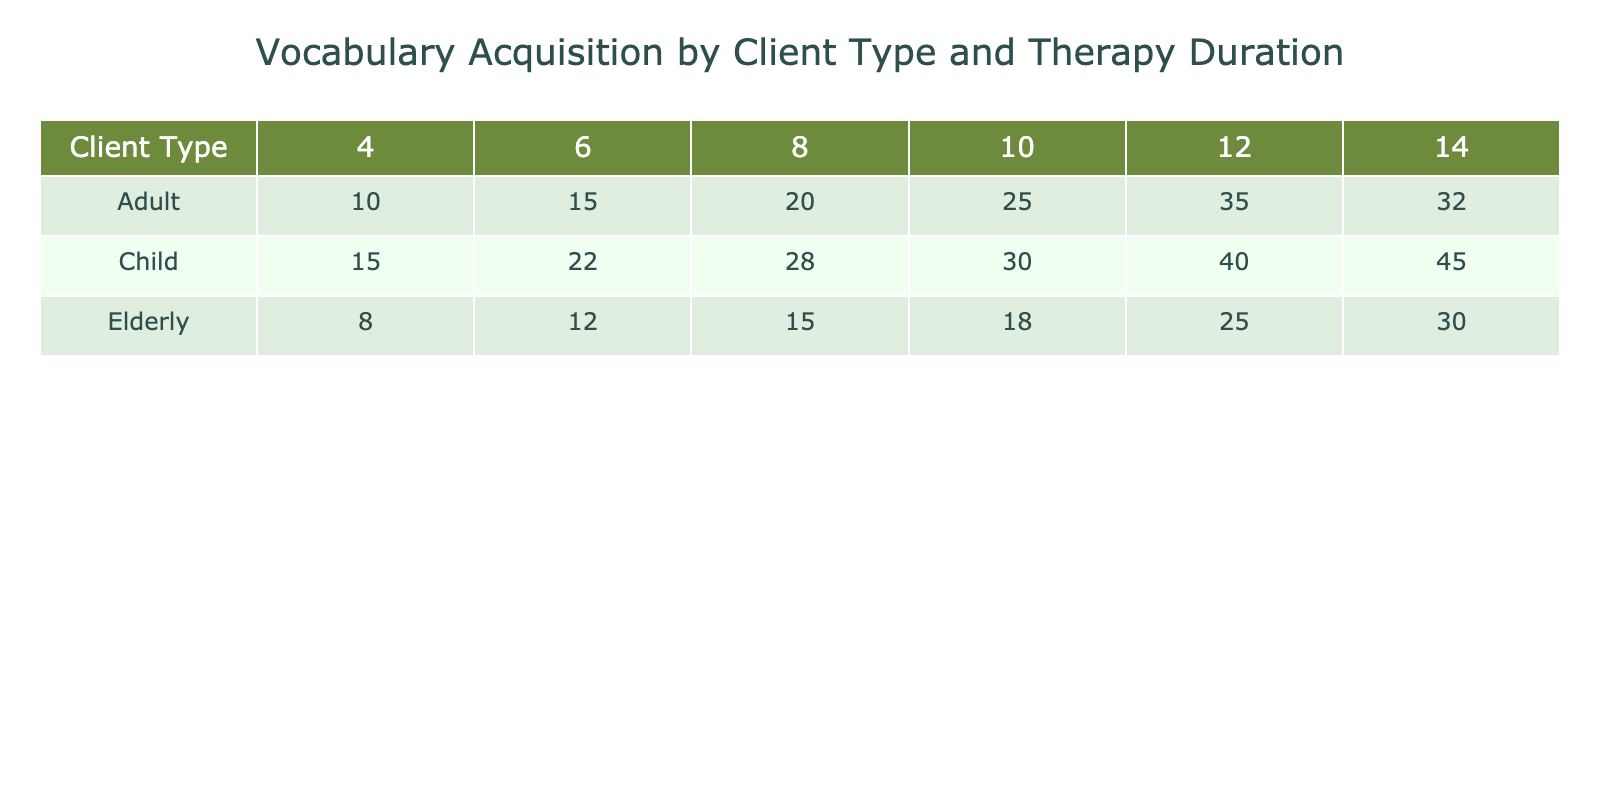What is the vocabulary acquisition score for children after 8 weeks of therapy? The table shows that children have a vocabulary acquisition score of 28 after 8 weeks of therapy.
Answer: 28 What is the highest vocabulary acquisition score achieved by elderly clients? Looking through the scores for elderly clients, the highest score is 30, which is achieved after 14 weeks of therapy.
Answer: 30 What is the average vocabulary acquisition score for adults across all therapy durations? To find the average score for adults, sum the scores (10 + 20 + 15 + 25 + 32) which equals 132. There are 5 data points, so the average is 132/5 = 26.4.
Answer: 26.4 Did elderly clients achieve a higher score after 12 weeks compared to after 8 weeks? After examining the two scores, elderly clients scored 25 after 12 weeks and 15 after 8 weeks. Thus, the score after 12 weeks is indeed higher than after 8 weeks.
Answer: Yes What is the difference in vocabulary acquisition scores between children and adults after 10 weeks? The score for children after 10 weeks is 30 and for adults, it is 25. The difference is calculated as 30 - 25 = 5.
Answer: 5 Which client type shows the greatest improvement in vocabulary acquisition from 4 to 14 weeks? For children, the score increases from 15 to 45 (an increase of 30). For adults, the score goes from 10 to 32 (an increase of 22). For elderly clients, it rises from 8 to 30 (an increase of 22). Therefore, children show the greatest improvement with an increase of 30.
Answer: Children What is the total vocabulary acquisition score for all client types after 6 weeks of therapy? The scores after 6 weeks are: children 22, adults 15, and elderly 12. Adding these together gives 22 + 15 + 12 = 49.
Answer: 49 Is there any client type that did not improve its score between 4 and 14 weeks? All client types showed score improvements over the given periods: Children improved from 15 to 45, adults from 10 to 32, and elderly from 8 to 30. Hence, no client type failed to improve.
Answer: No What is the percentage increase in vocabulary acquisition for children from 4 weeks to 12 weeks? Children’s score increased from 15 to 40. The increase is 40 - 15 = 25. The percentage increase is calculated as (25/15) * 100 = 166.67%.
Answer: 166.67% 